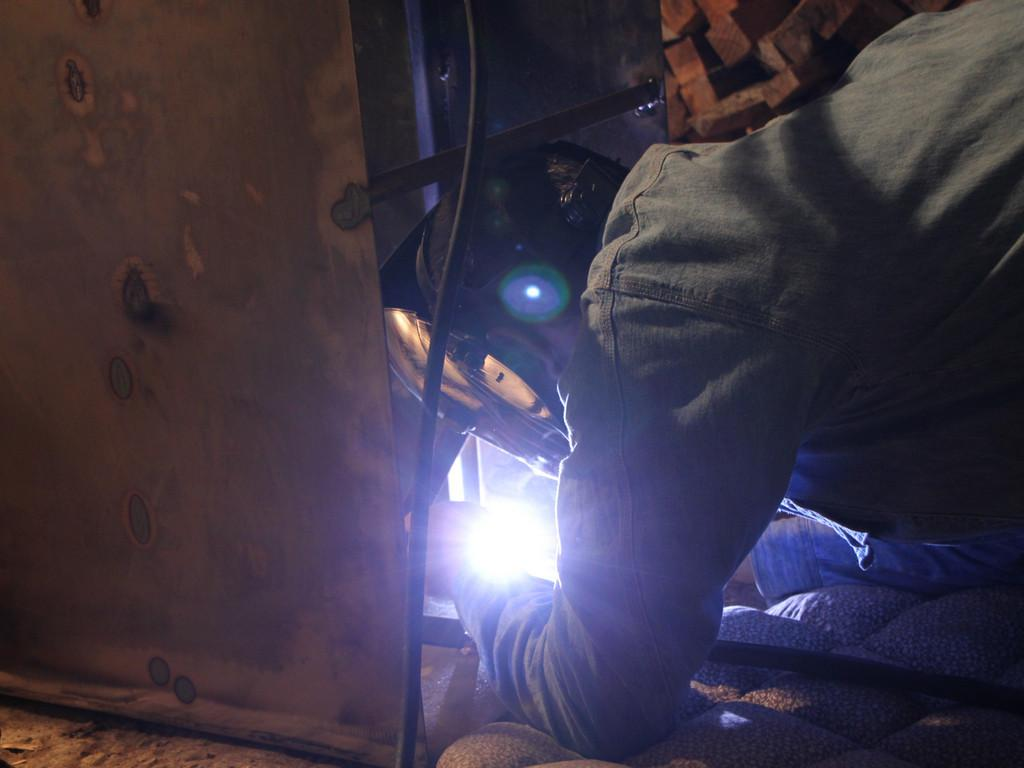What is located on the right side of the image? There is a man on the right side of the image. What can be seen in the middle of the image? There is an electrical equipment and light in the middle of the image. What is on the left side of the image? There is a cloth on the left side of the image. Where is the baby located in the image? There is no baby present in the image. What discovery was made in the image? There is no mention of a discovery in the image. 